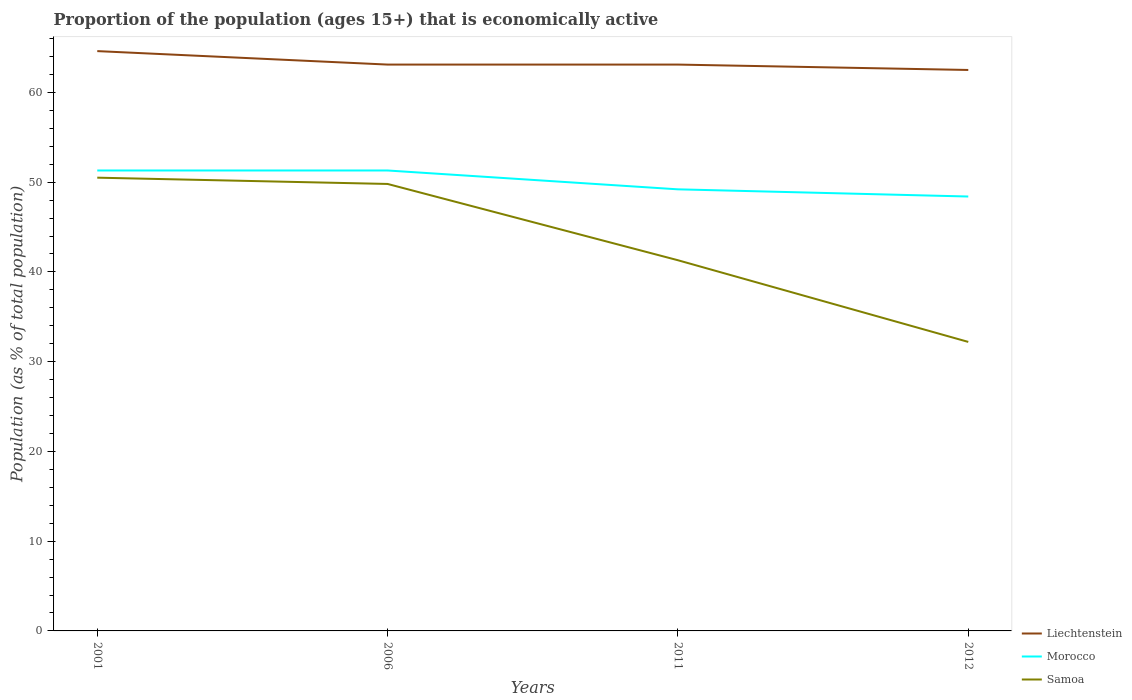Does the line corresponding to Samoa intersect with the line corresponding to Liechtenstein?
Give a very brief answer. No. Is the number of lines equal to the number of legend labels?
Your answer should be compact. Yes. Across all years, what is the maximum proportion of the population that is economically active in Liechtenstein?
Ensure brevity in your answer.  62.5. What is the total proportion of the population that is economically active in Liechtenstein in the graph?
Offer a very short reply. 0.6. What is the difference between the highest and the second highest proportion of the population that is economically active in Liechtenstein?
Your response must be concise. 2.1. What is the difference between the highest and the lowest proportion of the population that is economically active in Morocco?
Your response must be concise. 2. Is the proportion of the population that is economically active in Morocco strictly greater than the proportion of the population that is economically active in Liechtenstein over the years?
Your answer should be very brief. Yes. What is the difference between two consecutive major ticks on the Y-axis?
Give a very brief answer. 10. Are the values on the major ticks of Y-axis written in scientific E-notation?
Ensure brevity in your answer.  No. How are the legend labels stacked?
Offer a terse response. Vertical. What is the title of the graph?
Your answer should be very brief. Proportion of the population (ages 15+) that is economically active. Does "Micronesia" appear as one of the legend labels in the graph?
Provide a succinct answer. No. What is the label or title of the Y-axis?
Offer a very short reply. Population (as % of total population). What is the Population (as % of total population) in Liechtenstein in 2001?
Ensure brevity in your answer.  64.6. What is the Population (as % of total population) of Morocco in 2001?
Your answer should be very brief. 51.3. What is the Population (as % of total population) in Samoa in 2001?
Offer a terse response. 50.5. What is the Population (as % of total population) in Liechtenstein in 2006?
Your answer should be compact. 63.1. What is the Population (as % of total population) of Morocco in 2006?
Your answer should be compact. 51.3. What is the Population (as % of total population) in Samoa in 2006?
Offer a terse response. 49.8. What is the Population (as % of total population) of Liechtenstein in 2011?
Your answer should be very brief. 63.1. What is the Population (as % of total population) in Morocco in 2011?
Offer a terse response. 49.2. What is the Population (as % of total population) of Samoa in 2011?
Your response must be concise. 41.3. What is the Population (as % of total population) in Liechtenstein in 2012?
Provide a succinct answer. 62.5. What is the Population (as % of total population) of Morocco in 2012?
Your response must be concise. 48.4. What is the Population (as % of total population) in Samoa in 2012?
Offer a terse response. 32.2. Across all years, what is the maximum Population (as % of total population) in Liechtenstein?
Keep it short and to the point. 64.6. Across all years, what is the maximum Population (as % of total population) in Morocco?
Provide a succinct answer. 51.3. Across all years, what is the maximum Population (as % of total population) in Samoa?
Give a very brief answer. 50.5. Across all years, what is the minimum Population (as % of total population) of Liechtenstein?
Give a very brief answer. 62.5. Across all years, what is the minimum Population (as % of total population) of Morocco?
Ensure brevity in your answer.  48.4. Across all years, what is the minimum Population (as % of total population) of Samoa?
Provide a short and direct response. 32.2. What is the total Population (as % of total population) of Liechtenstein in the graph?
Provide a short and direct response. 253.3. What is the total Population (as % of total population) in Morocco in the graph?
Give a very brief answer. 200.2. What is the total Population (as % of total population) in Samoa in the graph?
Ensure brevity in your answer.  173.8. What is the difference between the Population (as % of total population) of Liechtenstein in 2001 and that in 2006?
Make the answer very short. 1.5. What is the difference between the Population (as % of total population) of Liechtenstein in 2001 and that in 2011?
Ensure brevity in your answer.  1.5. What is the difference between the Population (as % of total population) of Morocco in 2001 and that in 2012?
Provide a short and direct response. 2.9. What is the difference between the Population (as % of total population) in Morocco in 2006 and that in 2011?
Provide a short and direct response. 2.1. What is the difference between the Population (as % of total population) of Liechtenstein in 2006 and that in 2012?
Keep it short and to the point. 0.6. What is the difference between the Population (as % of total population) of Morocco in 2011 and that in 2012?
Ensure brevity in your answer.  0.8. What is the difference between the Population (as % of total population) of Samoa in 2011 and that in 2012?
Your answer should be compact. 9.1. What is the difference between the Population (as % of total population) of Liechtenstein in 2001 and the Population (as % of total population) of Morocco in 2006?
Offer a terse response. 13.3. What is the difference between the Population (as % of total population) in Liechtenstein in 2001 and the Population (as % of total population) in Samoa in 2006?
Give a very brief answer. 14.8. What is the difference between the Population (as % of total population) in Liechtenstein in 2001 and the Population (as % of total population) in Morocco in 2011?
Keep it short and to the point. 15.4. What is the difference between the Population (as % of total population) in Liechtenstein in 2001 and the Population (as % of total population) in Samoa in 2011?
Ensure brevity in your answer.  23.3. What is the difference between the Population (as % of total population) of Morocco in 2001 and the Population (as % of total population) of Samoa in 2011?
Provide a succinct answer. 10. What is the difference between the Population (as % of total population) of Liechtenstein in 2001 and the Population (as % of total population) of Samoa in 2012?
Offer a terse response. 32.4. What is the difference between the Population (as % of total population) in Liechtenstein in 2006 and the Population (as % of total population) in Morocco in 2011?
Your answer should be compact. 13.9. What is the difference between the Population (as % of total population) of Liechtenstein in 2006 and the Population (as % of total population) of Samoa in 2011?
Offer a very short reply. 21.8. What is the difference between the Population (as % of total population) in Morocco in 2006 and the Population (as % of total population) in Samoa in 2011?
Your response must be concise. 10. What is the difference between the Population (as % of total population) in Liechtenstein in 2006 and the Population (as % of total population) in Samoa in 2012?
Your response must be concise. 30.9. What is the difference between the Population (as % of total population) of Liechtenstein in 2011 and the Population (as % of total population) of Morocco in 2012?
Ensure brevity in your answer.  14.7. What is the difference between the Population (as % of total population) in Liechtenstein in 2011 and the Population (as % of total population) in Samoa in 2012?
Your answer should be very brief. 30.9. What is the difference between the Population (as % of total population) in Morocco in 2011 and the Population (as % of total population) in Samoa in 2012?
Your answer should be compact. 17. What is the average Population (as % of total population) in Liechtenstein per year?
Ensure brevity in your answer.  63.33. What is the average Population (as % of total population) of Morocco per year?
Your answer should be very brief. 50.05. What is the average Population (as % of total population) of Samoa per year?
Provide a short and direct response. 43.45. In the year 2001, what is the difference between the Population (as % of total population) in Liechtenstein and Population (as % of total population) in Morocco?
Make the answer very short. 13.3. In the year 2001, what is the difference between the Population (as % of total population) of Liechtenstein and Population (as % of total population) of Samoa?
Give a very brief answer. 14.1. In the year 2011, what is the difference between the Population (as % of total population) of Liechtenstein and Population (as % of total population) of Morocco?
Make the answer very short. 13.9. In the year 2011, what is the difference between the Population (as % of total population) of Liechtenstein and Population (as % of total population) of Samoa?
Your response must be concise. 21.8. In the year 2012, what is the difference between the Population (as % of total population) in Liechtenstein and Population (as % of total population) in Samoa?
Give a very brief answer. 30.3. In the year 2012, what is the difference between the Population (as % of total population) in Morocco and Population (as % of total population) in Samoa?
Your response must be concise. 16.2. What is the ratio of the Population (as % of total population) in Liechtenstein in 2001 to that in 2006?
Your answer should be very brief. 1.02. What is the ratio of the Population (as % of total population) in Samoa in 2001 to that in 2006?
Provide a short and direct response. 1.01. What is the ratio of the Population (as % of total population) in Liechtenstein in 2001 to that in 2011?
Provide a short and direct response. 1.02. What is the ratio of the Population (as % of total population) of Morocco in 2001 to that in 2011?
Offer a terse response. 1.04. What is the ratio of the Population (as % of total population) in Samoa in 2001 to that in 2011?
Ensure brevity in your answer.  1.22. What is the ratio of the Population (as % of total population) of Liechtenstein in 2001 to that in 2012?
Keep it short and to the point. 1.03. What is the ratio of the Population (as % of total population) of Morocco in 2001 to that in 2012?
Offer a very short reply. 1.06. What is the ratio of the Population (as % of total population) of Samoa in 2001 to that in 2012?
Your answer should be compact. 1.57. What is the ratio of the Population (as % of total population) in Morocco in 2006 to that in 2011?
Give a very brief answer. 1.04. What is the ratio of the Population (as % of total population) of Samoa in 2006 to that in 2011?
Your response must be concise. 1.21. What is the ratio of the Population (as % of total population) in Liechtenstein in 2006 to that in 2012?
Your response must be concise. 1.01. What is the ratio of the Population (as % of total population) in Morocco in 2006 to that in 2012?
Your answer should be compact. 1.06. What is the ratio of the Population (as % of total population) in Samoa in 2006 to that in 2012?
Offer a very short reply. 1.55. What is the ratio of the Population (as % of total population) in Liechtenstein in 2011 to that in 2012?
Give a very brief answer. 1.01. What is the ratio of the Population (as % of total population) of Morocco in 2011 to that in 2012?
Provide a short and direct response. 1.02. What is the ratio of the Population (as % of total population) in Samoa in 2011 to that in 2012?
Give a very brief answer. 1.28. What is the difference between the highest and the second highest Population (as % of total population) of Liechtenstein?
Your response must be concise. 1.5. What is the difference between the highest and the second highest Population (as % of total population) in Morocco?
Give a very brief answer. 0. What is the difference between the highest and the lowest Population (as % of total population) of Samoa?
Keep it short and to the point. 18.3. 